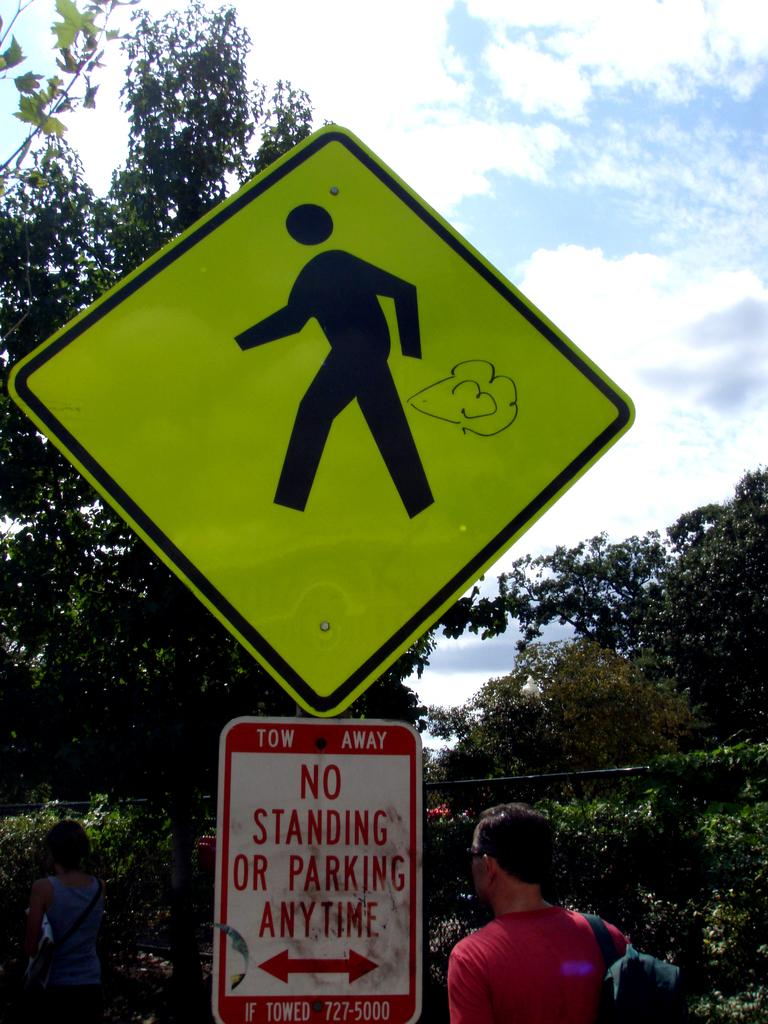How many people are in the image? There are two persons in the image. What else can be seen in the image besides the people? There are two sign boards and a metal fence at the center of the image. What can be seen in the background of the image? There are trees and the sky visible in the background of the image. What type of soda is being advertised on the sign boards in the image? There is no soda or any advertisements on the sign boards in the image. What is the texture of the metal fence in the image? The texture of the metal fence cannot be definitively determined from the image. 